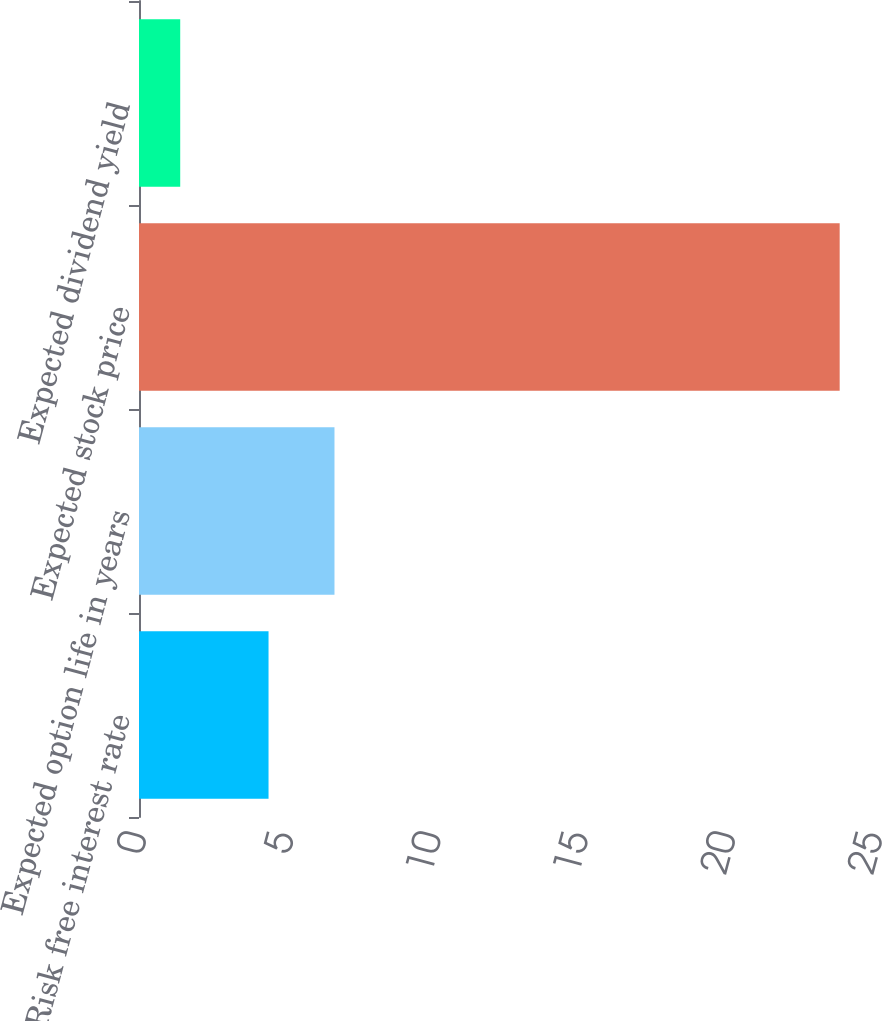<chart> <loc_0><loc_0><loc_500><loc_500><bar_chart><fcel>Risk free interest rate<fcel>Expected option life in years<fcel>Expected stock price<fcel>Expected dividend yield<nl><fcel>4.4<fcel>6.64<fcel>23.8<fcel>1.4<nl></chart> 